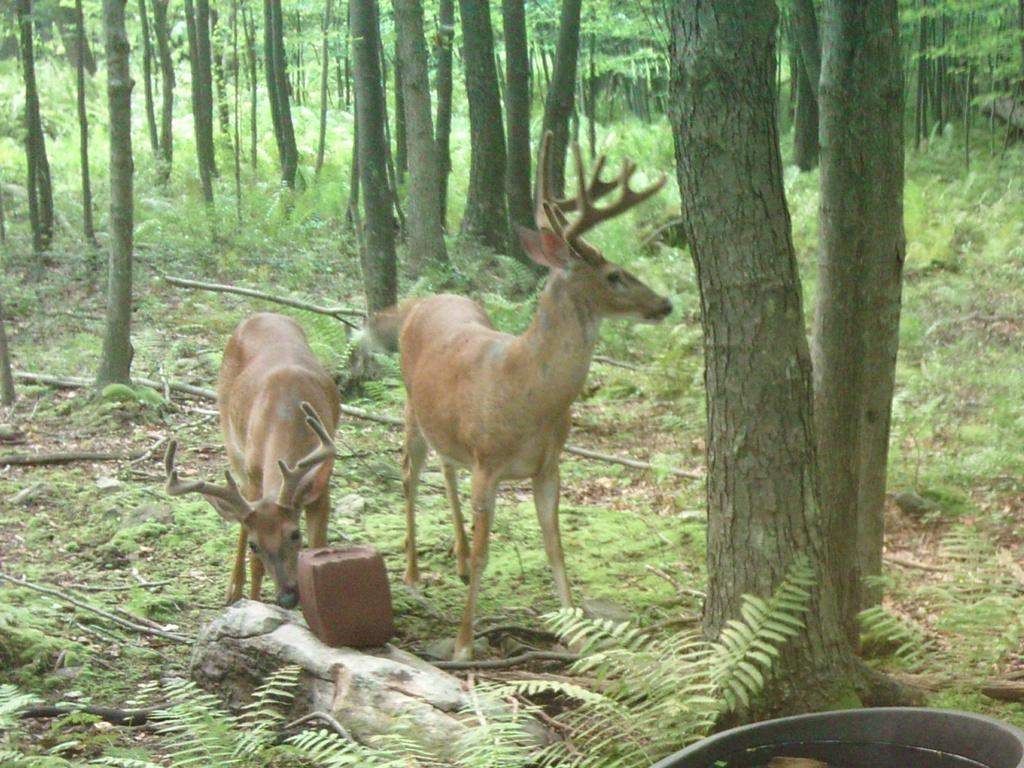Please provide a concise description of this image. In this image I can see two animals standing, they are in brown color. Background I can see trees in green color. 